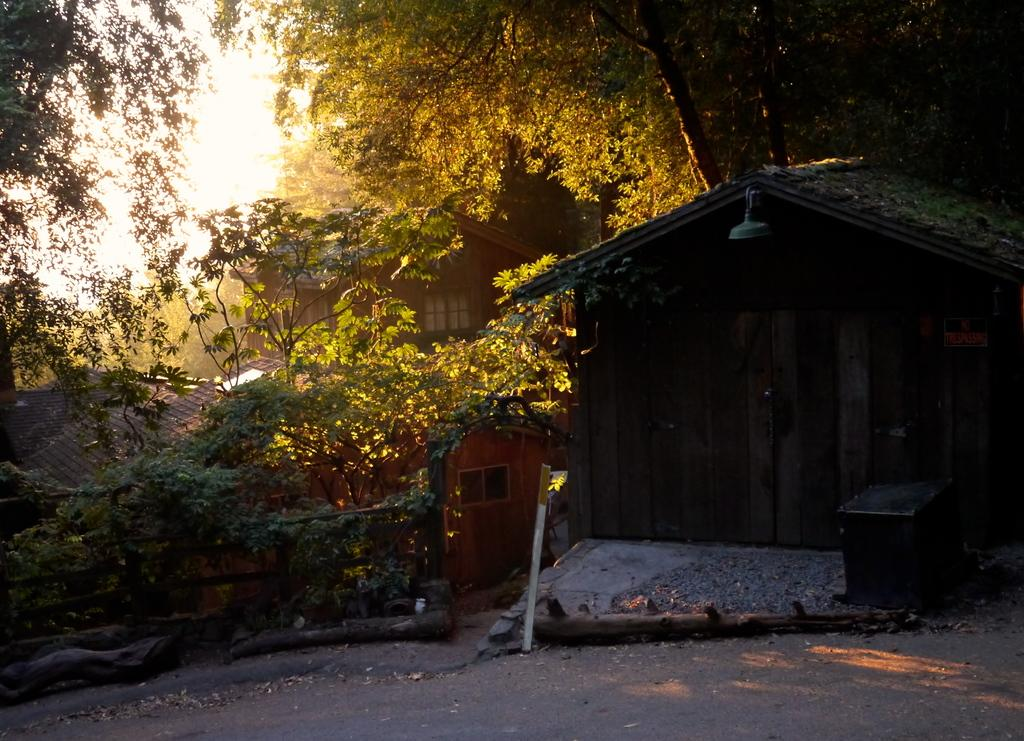What is located on the right side of the image? There is a room on the right side of the image. What type of natural elements can be seen in the image? Trees and the sky are visible in the image. What material is present in the image? Wood is present in the image. What type of fruit is hanging from the trees in the image? There is no fruit visible in the image; only trees are present. How does the friction between the wood and the room affect the temperature in the image? The image does not provide information about the temperature or the friction between the wood and the room, so it cannot be determined from the image. 